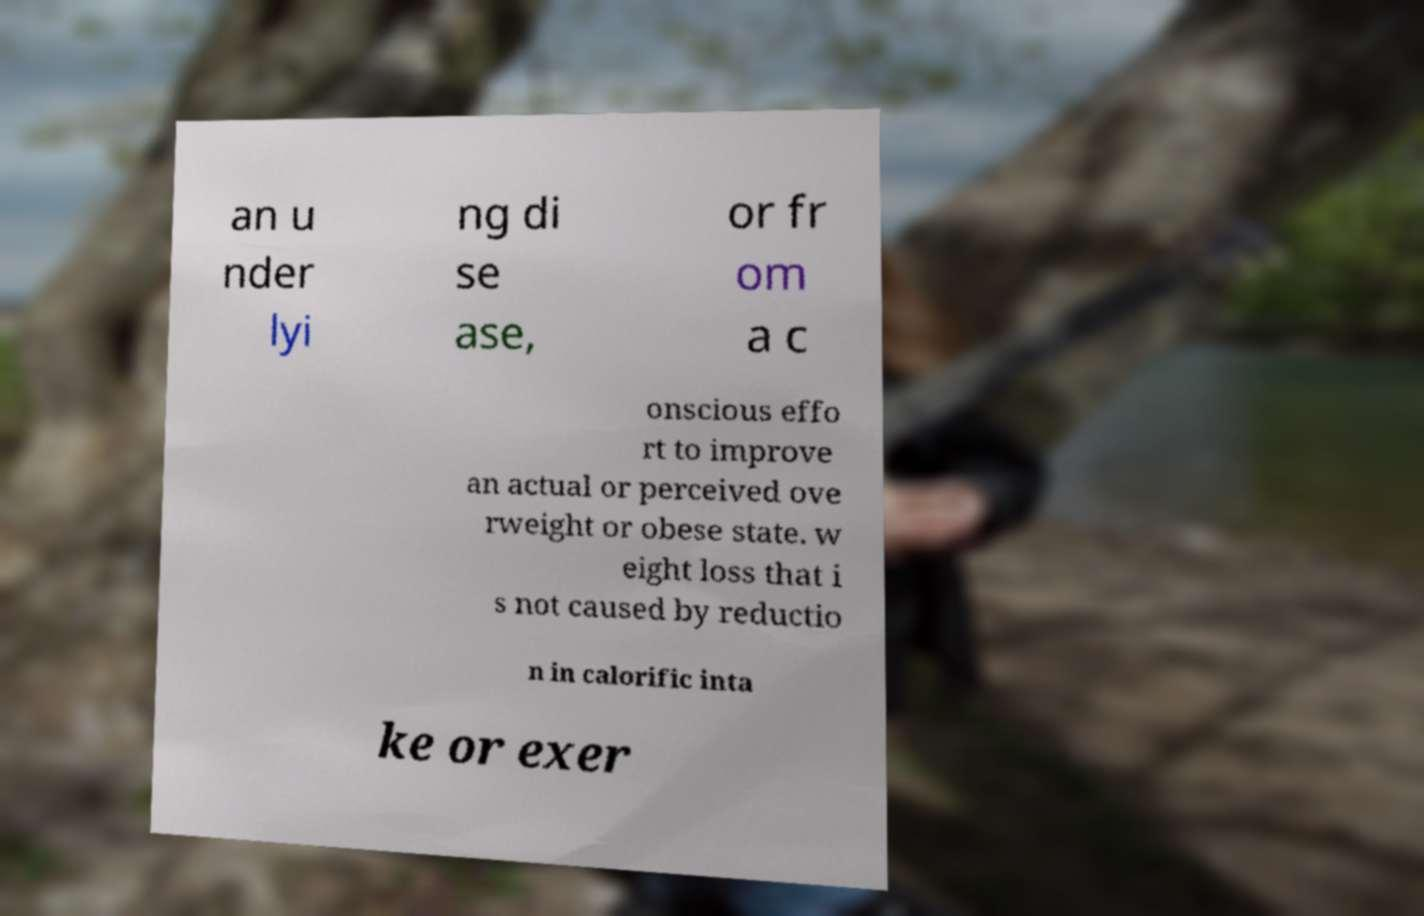Could you extract and type out the text from this image? an u nder lyi ng di se ase, or fr om a c onscious effo rt to improve an actual or perceived ove rweight or obese state. w eight loss that i s not caused by reductio n in calorific inta ke or exer 